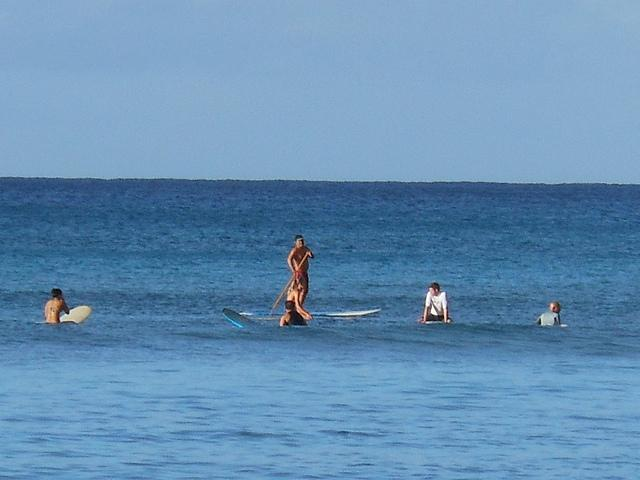What is the man who is standing doing?

Choices:
A) jumping
B) waving
C) rowing
D) eating rowing 